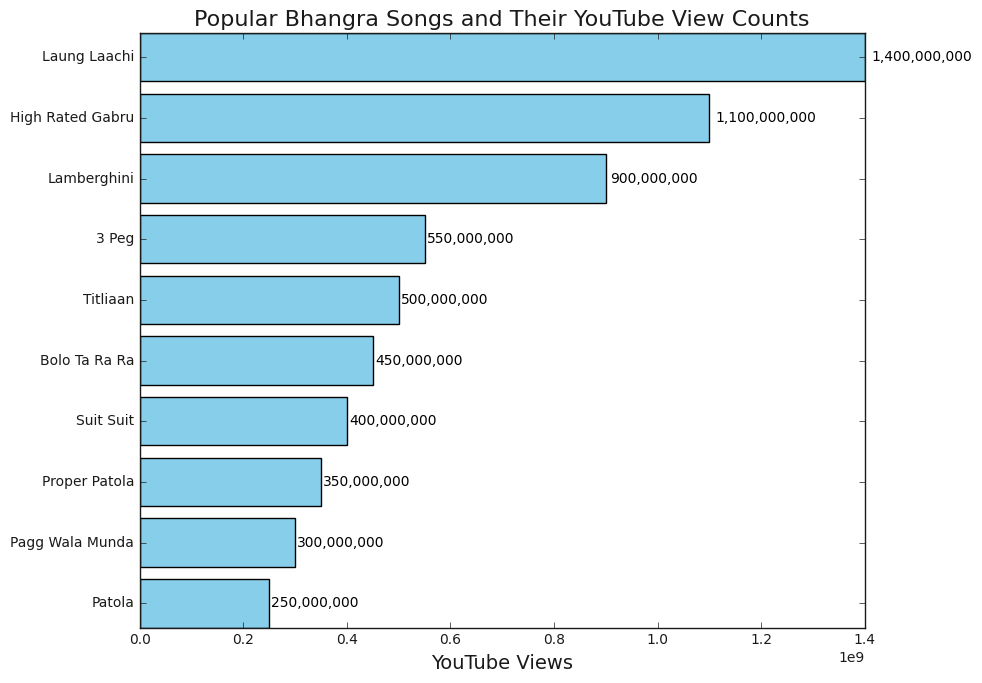Which song has the highest number of YouTube views? The bar chart shows the YouTube views for each song in descending order, and the longest bar represents the highest number of views. The song "Laung Laachi" has the longest bar.
Answer: Laung Laachi What is the difference in YouTube views between "Lamberghini" and "Patola"? To find the difference, locate the bars for "Lamberghini" and "Patola," and note their view counts. "Lamberghini" has 900 million views, and "Patola" has 250 million views. The difference is 900M - 250M = 650 million views.
Answer: 650M How many songs have more than 500 million YouTube views? Count the bars that represent songs with more than 500 million views. The bars for "Laung Laachi," "High Rated Gabru," and "Lamberghini" meet this criterion. There are three such songs.
Answer: 3 Which song has smaller YouTube views, "Suit Suit" or "3 Peg"? Compare the lengths of the bars for "Suit Suit" and "3 Peg." The bar for "Suit Suit" is shorter, indicating it has fewer views.
Answer: Suit Suit What are the total YouTube views for the top three songs combined? Sum the views for the top three songs: "Laung Laachi" (1.4B), "High Rated Gabru" (1.1B), and "Lamberghini" (900M). Converting all values to billions for ease: 1.4 + 1.1 + 0.9 = 3.4B or 3,400 million views.
Answer: 3.4B What is the average number of YouTube views for the songs in the chart? Calculate the average by summing all the YouTube views and dividing by the number of songs. The total views are 1.4B + 1.1B + 900M + 550M + 500M + 450M + 400M + 350M + 300M + 250M = 6.2B or 6,200 million views and there are 10 songs: 6,200M / 10 = 620M views.
Answer: 620M Which song has a YouTube view count closest to the average view count? First, calculate the average YouTube views, which is 620 million. Find the bar closest to this average. "3 Peg" with 550 million views is closest to 620 million.
Answer: 3 Peg 